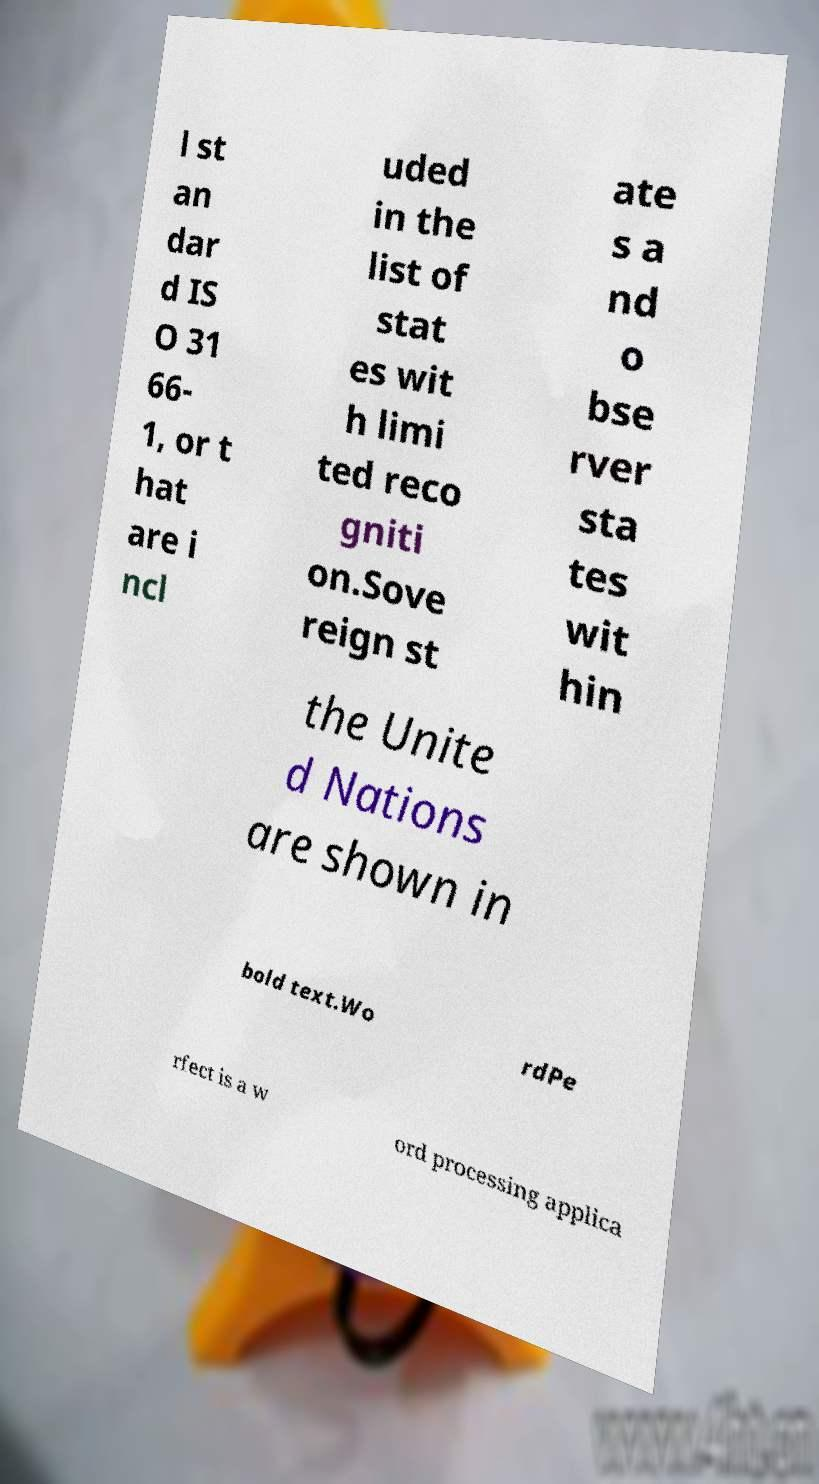For documentation purposes, I need the text within this image transcribed. Could you provide that? l st an dar d IS O 31 66- 1, or t hat are i ncl uded in the list of stat es wit h limi ted reco gniti on.Sove reign st ate s a nd o bse rver sta tes wit hin the Unite d Nations are shown in bold text.Wo rdPe rfect is a w ord processing applica 